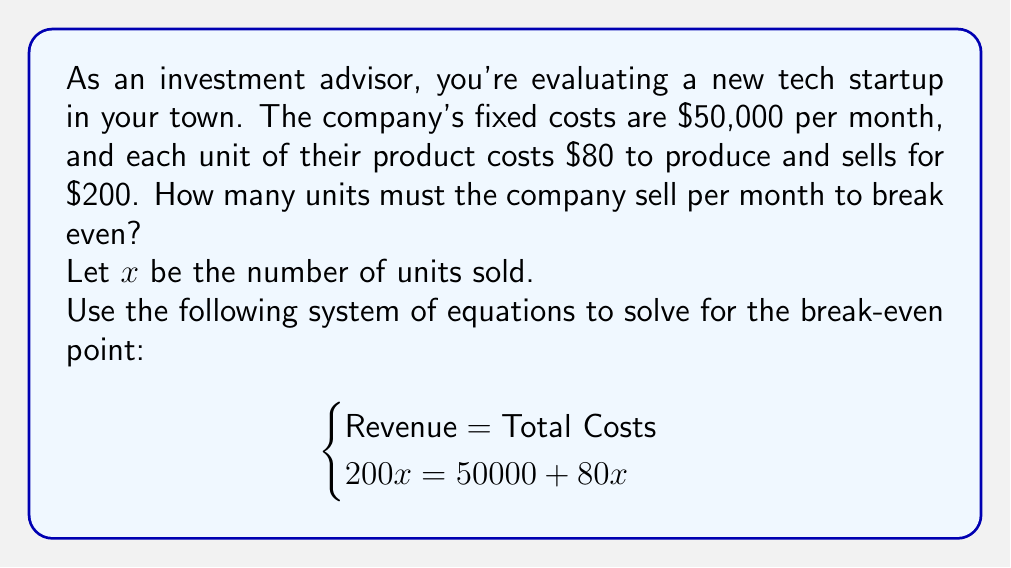What is the answer to this math problem? Let's solve this step-by-step:

1) We start with the equation:
   $200x = 50000 + 80x$

2) Subtract $80x$ from both sides:
   $200x - 80x = 50000 + 80x - 80x$
   $120x = 50000$

3) Divide both sides by 120:
   $\frac{120x}{120} = \frac{50000}{120}$
   $x = \frac{50000}{120}$

4) Simplify the fraction:
   $x = \frac{25000}{60}$
   $x = 416.67$

5) Since we can't sell a fraction of a unit, we round up to the nearest whole number:
   $x = 417$

Therefore, the company needs to sell 417 units per month to break even.

To verify:
Revenue: $200 * 417 = 83400$
Total Costs: $50000 + (80 * 417) = 83360$

The slight difference is due to rounding, but this is the minimum number of units to exceed the break-even point.
Answer: 417 units 